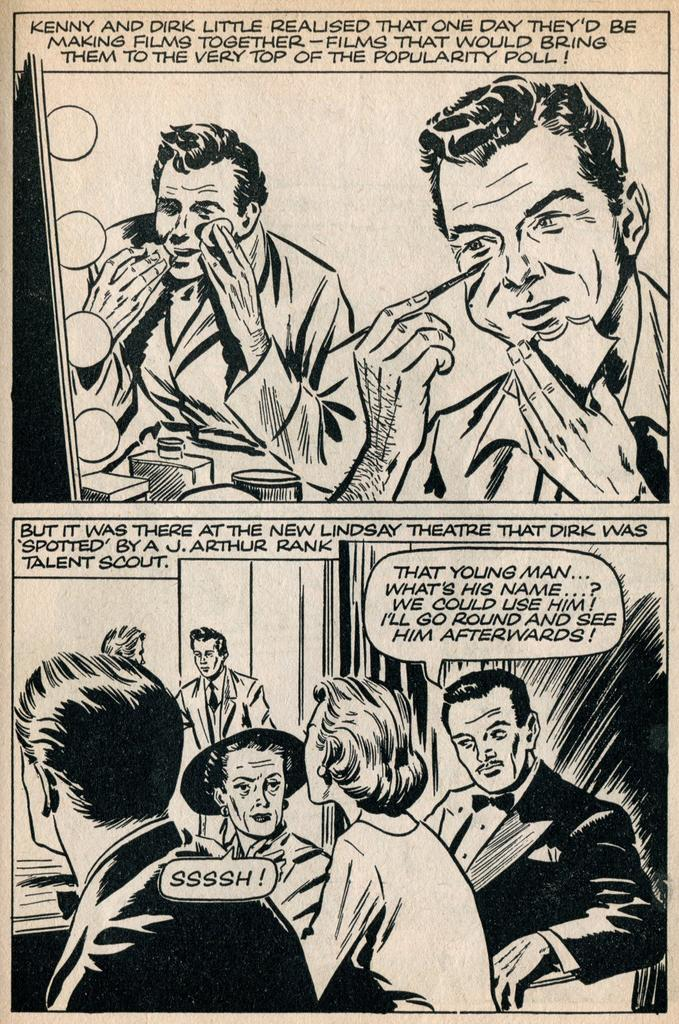<image>
Summarize the visual content of the image. A black and white comic strip includes a character named Lindsay. 